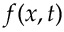<formula> <loc_0><loc_0><loc_500><loc_500>f ( x , t )</formula> 